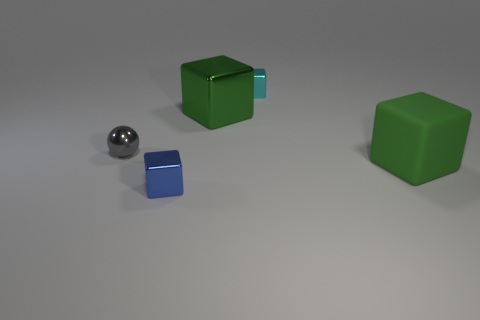Subtract 1 cubes. How many cubes are left? 3 Add 2 tiny gray spheres. How many objects exist? 7 Subtract all cubes. How many objects are left? 1 Add 5 purple metallic objects. How many purple metallic objects exist? 5 Subtract 0 red cylinders. How many objects are left? 5 Subtract all small green rubber blocks. Subtract all small blue cubes. How many objects are left? 4 Add 3 matte blocks. How many matte blocks are left? 4 